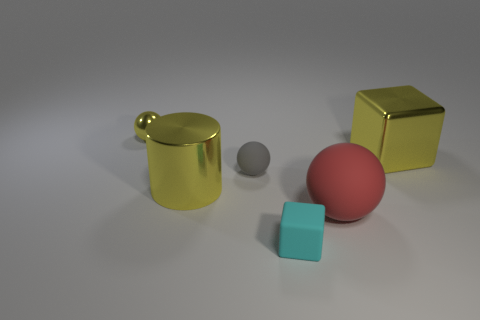Does the large yellow metal thing to the right of the red ball have the same shape as the cyan rubber thing?
Ensure brevity in your answer.  Yes. What number of large yellow cylinders are made of the same material as the yellow block?
Keep it short and to the point. 1. What number of objects are metal objects that are right of the tiny yellow metallic object or large blue shiny spheres?
Keep it short and to the point. 2. How big is the red thing?
Your response must be concise. Large. What is the material of the small sphere in front of the tiny object behind the tiny gray matte object?
Provide a short and direct response. Rubber. Is the size of the yellow metal thing that is right of the gray sphere the same as the red matte ball?
Make the answer very short. Yes. Are there any large metal cylinders that have the same color as the small shiny thing?
Provide a succinct answer. Yes. What number of things are big metallic things that are to the left of the tiny cyan thing or small things right of the gray thing?
Your answer should be compact. 2. Do the big cylinder and the tiny shiny sphere have the same color?
Offer a terse response. Yes. There is a tiny object that is the same color as the large metallic cylinder; what material is it?
Give a very brief answer. Metal. 